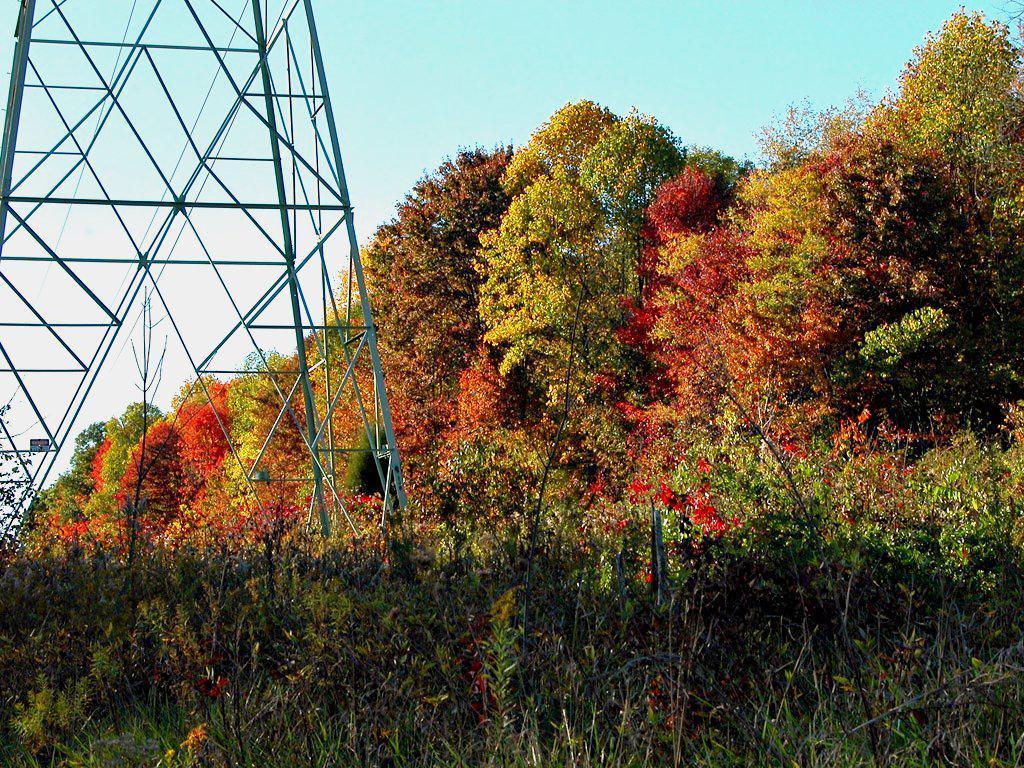Can you describe this image briefly? At the bottom we can see plants and trees. On the left there is a tower. In the background there are trees and clouds in the sky. 